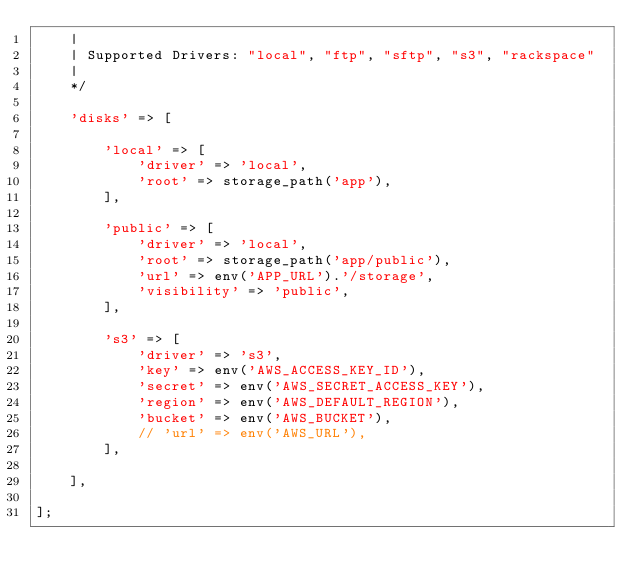<code> <loc_0><loc_0><loc_500><loc_500><_PHP_>    |
    | Supported Drivers: "local", "ftp", "sftp", "s3", "rackspace"
    |
    */

    'disks' => [

        'local' => [
            'driver' => 'local',
            'root' => storage_path('app'),
        ],

        'public' => [
            'driver' => 'local',
            'root' => storage_path('app/public'),
            'url' => env('APP_URL').'/storage',
            'visibility' => 'public',
        ],

        's3' => [
            'driver' => 's3',
            'key' => env('AWS_ACCESS_KEY_ID'),
            'secret' => env('AWS_SECRET_ACCESS_KEY'),
            'region' => env('AWS_DEFAULT_REGION'),
            'bucket' => env('AWS_BUCKET'),
            // 'url' => env('AWS_URL'),
        ],

    ],

];
</code> 